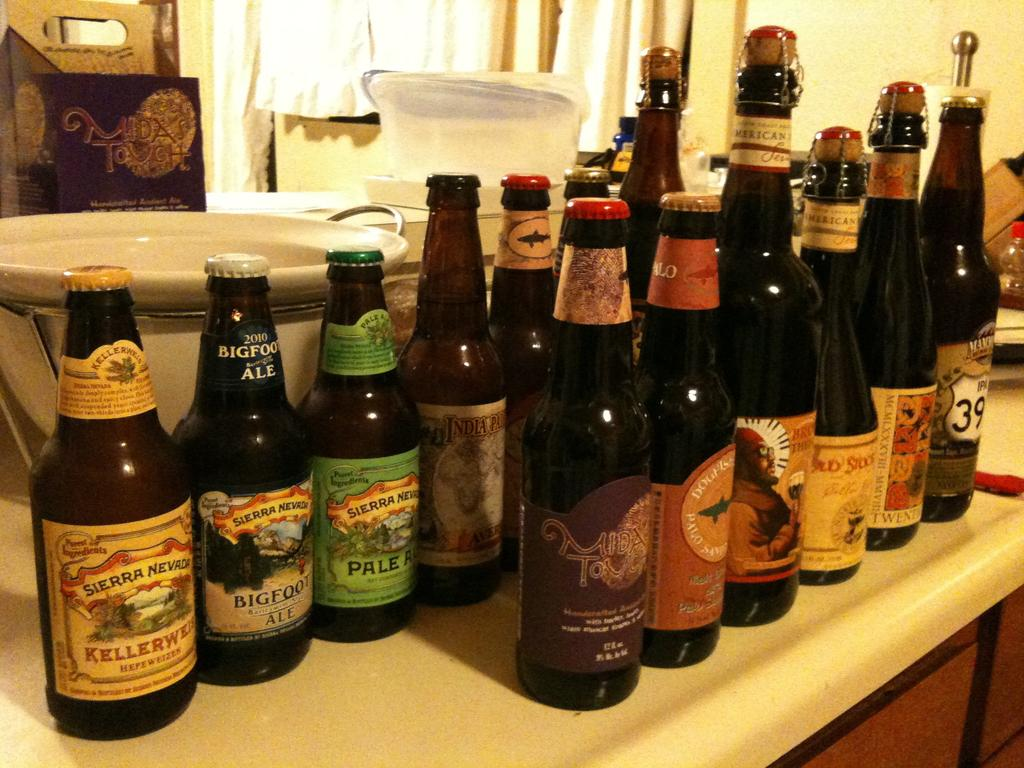<image>
Create a compact narrative representing the image presented. rows of bottles including sierra nevada kellerweis, bigfoot ale, and pale ale 